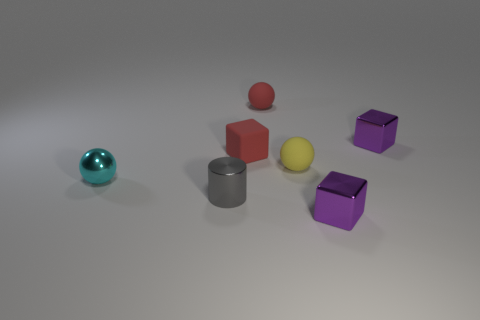There is a rubber sphere that is the same color as the rubber block; what is its size?
Provide a short and direct response. Small. Are there any yellow objects made of the same material as the tiny yellow sphere?
Your answer should be compact. No. Are there any small matte cubes to the right of the purple cube in front of the cyan object?
Offer a terse response. No. What is the material of the purple cube that is in front of the tiny red block?
Your response must be concise. Metal. Is the shape of the cyan object the same as the small gray shiny object?
Provide a short and direct response. No. What color is the small block to the left of the sphere that is behind the tiny purple cube that is behind the cylinder?
Give a very brief answer. Red. How many small purple things are the same shape as the small yellow matte object?
Give a very brief answer. 0. What size is the shiny object that is behind the red rubber object that is in front of the tiny red matte sphere?
Give a very brief answer. Small. Do the cyan sphere and the matte block have the same size?
Provide a short and direct response. Yes. Are there any small purple cubes that are behind the tiny matte ball that is behind the small purple metallic block behind the tiny red matte cube?
Your answer should be very brief. No. 